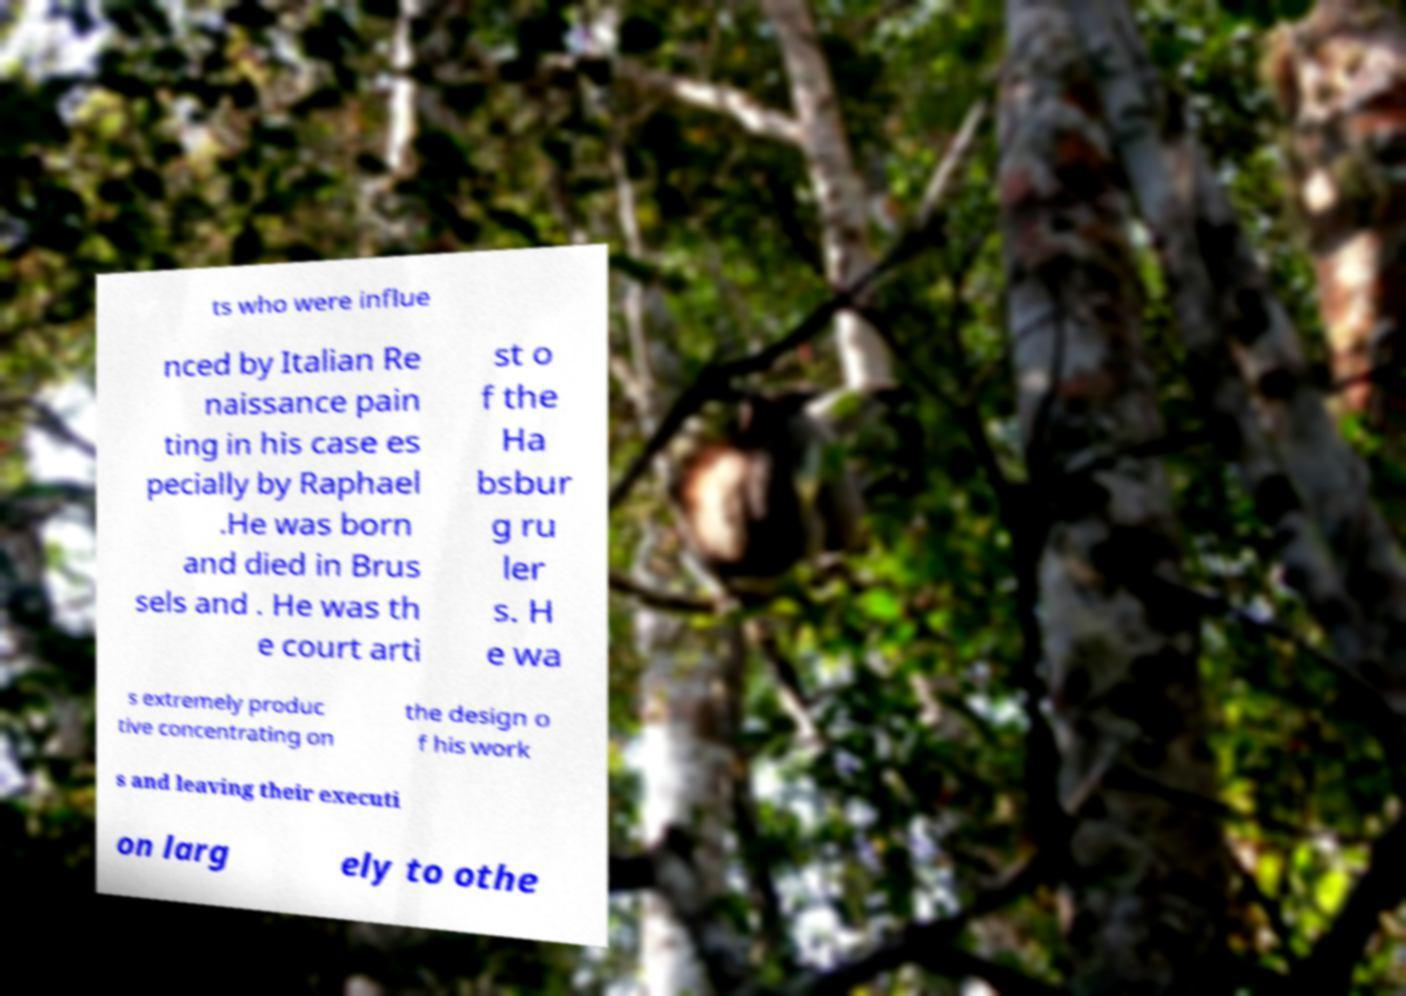Please identify and transcribe the text found in this image. ts who were influe nced by Italian Re naissance pain ting in his case es pecially by Raphael .He was born and died in Brus sels and . He was th e court arti st o f the Ha bsbur g ru ler s. H e wa s extremely produc tive concentrating on the design o f his work s and leaving their executi on larg ely to othe 